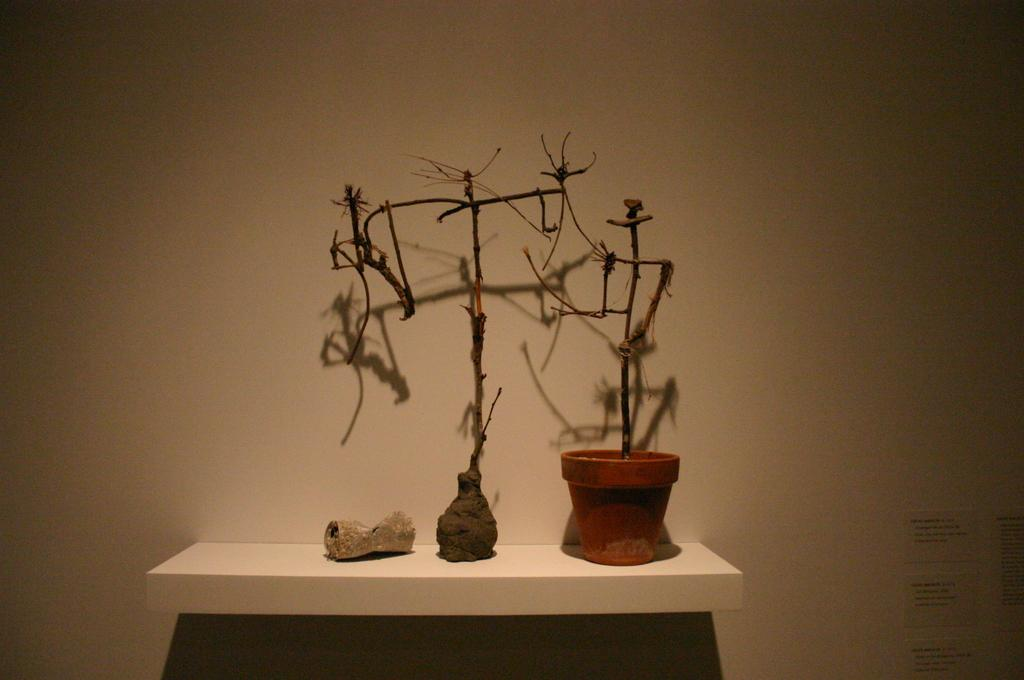What is present behind the shelf in the image? There is a wall in the image. What is on the wall in the image? The shadow of the plant is being reflected on the wall. What can be seen on the shelf in the image? There is a dry plant and two other objects on the shelf. Can you describe the condition of the plant on the shelf? The plant on the shelf is dry. How many horses are visible in the image? There are no horses present in the image. What type of chicken is being cooked on the shelf in the image? There is no chicken present in the image; it features a dry plant and two other objects on the shelf. 